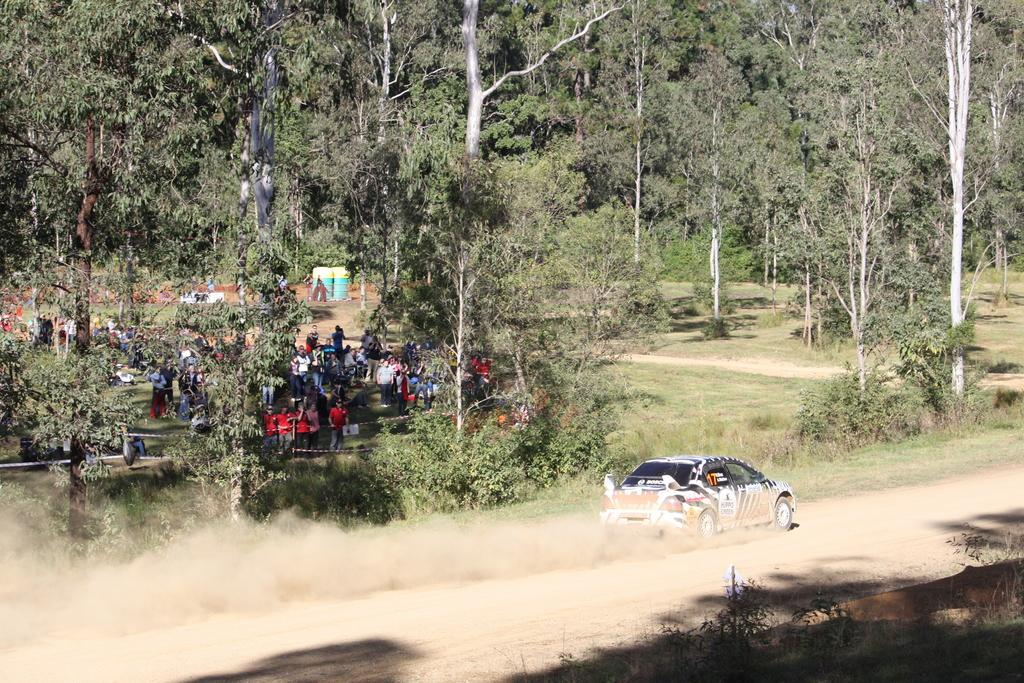What type of vegetation can be seen at the top of the image? There are trees at the top of the image. What is located at the bottom of the image? There is a crowd, the ground, grass, plants, and a motor vehicle at the bottom of the image. What type of surface is visible at the bottom of the image? The ground and sand are visible at the bottom of the image. What might be used for cleaning or wiping in the image? There is no basin present in the image for cleaning or wiping. How many buns are visible in the image? There are no buns present in the image. What type of footwear is the crowd wearing in the image? There is no information about the footwear of the crowd in the image. 